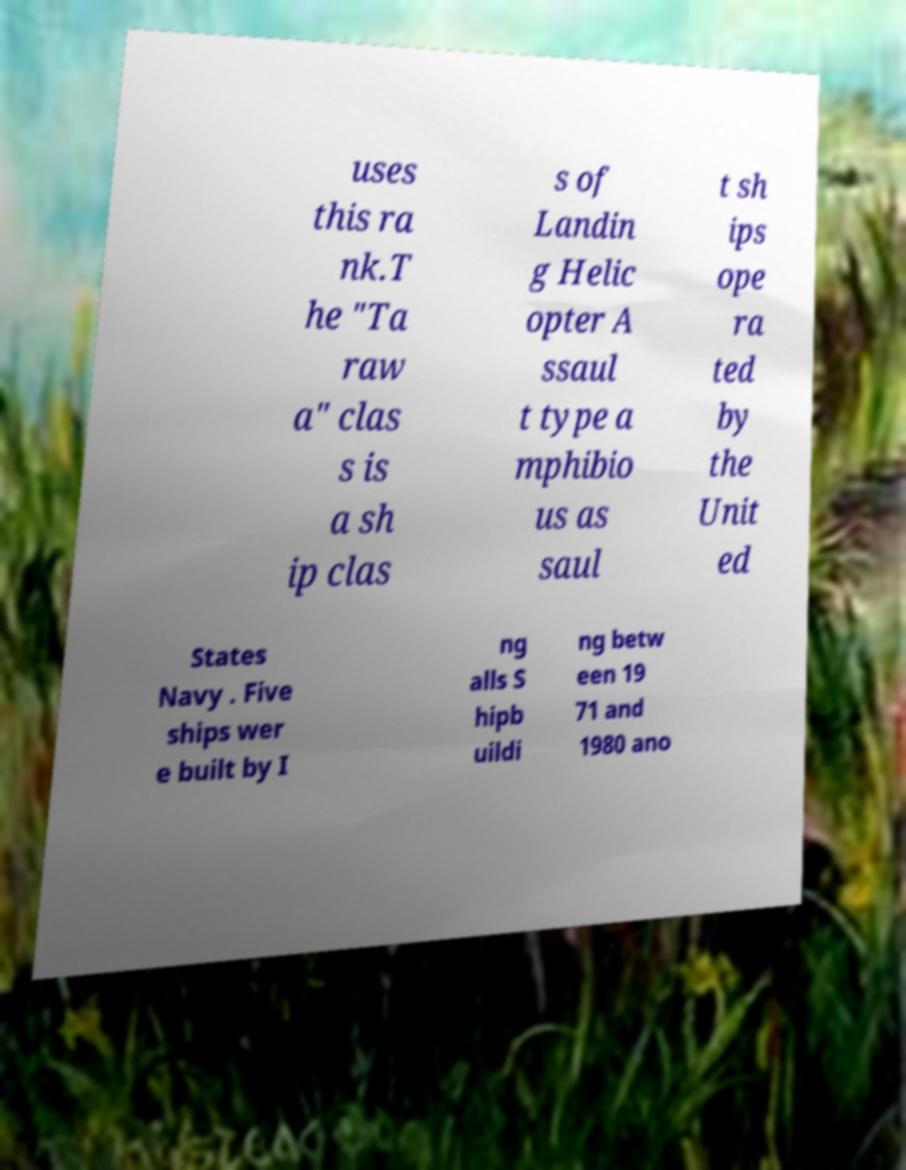I need the written content from this picture converted into text. Can you do that? uses this ra nk.T he "Ta raw a" clas s is a sh ip clas s of Landin g Helic opter A ssaul t type a mphibio us as saul t sh ips ope ra ted by the Unit ed States Navy . Five ships wer e built by I ng alls S hipb uildi ng betw een 19 71 and 1980 ano 